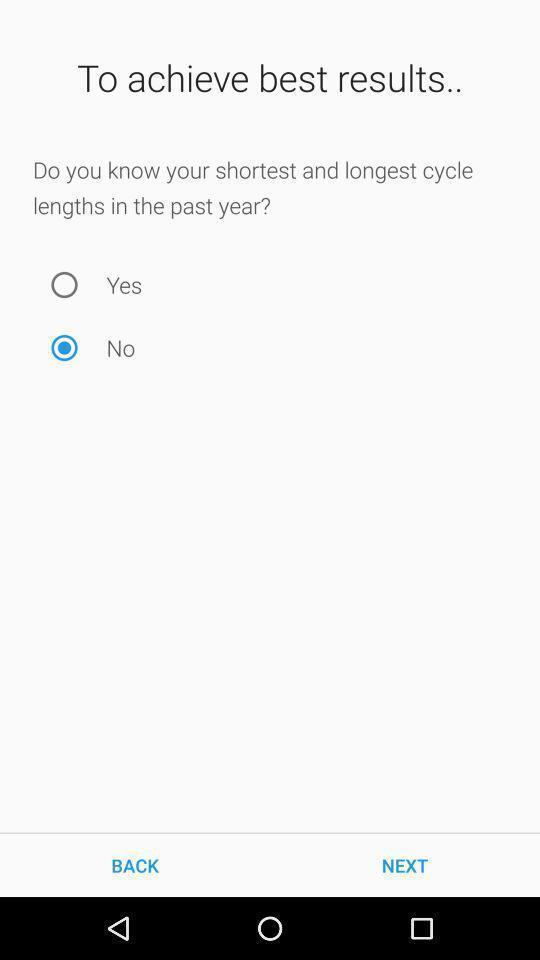Give me a narrative description of this picture. Yes or no options page in a fertility app. 